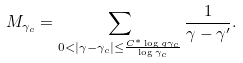Convert formula to latex. <formula><loc_0><loc_0><loc_500><loc_500>M _ { \gamma _ { c } } = \sum _ { 0 < | \gamma - \gamma _ { c } | \leq \frac { C ^ { * } \log g \gamma _ { c } } { \log \gamma _ { c } } } \frac { 1 } { \gamma - \gamma ^ { \prime } } .</formula> 